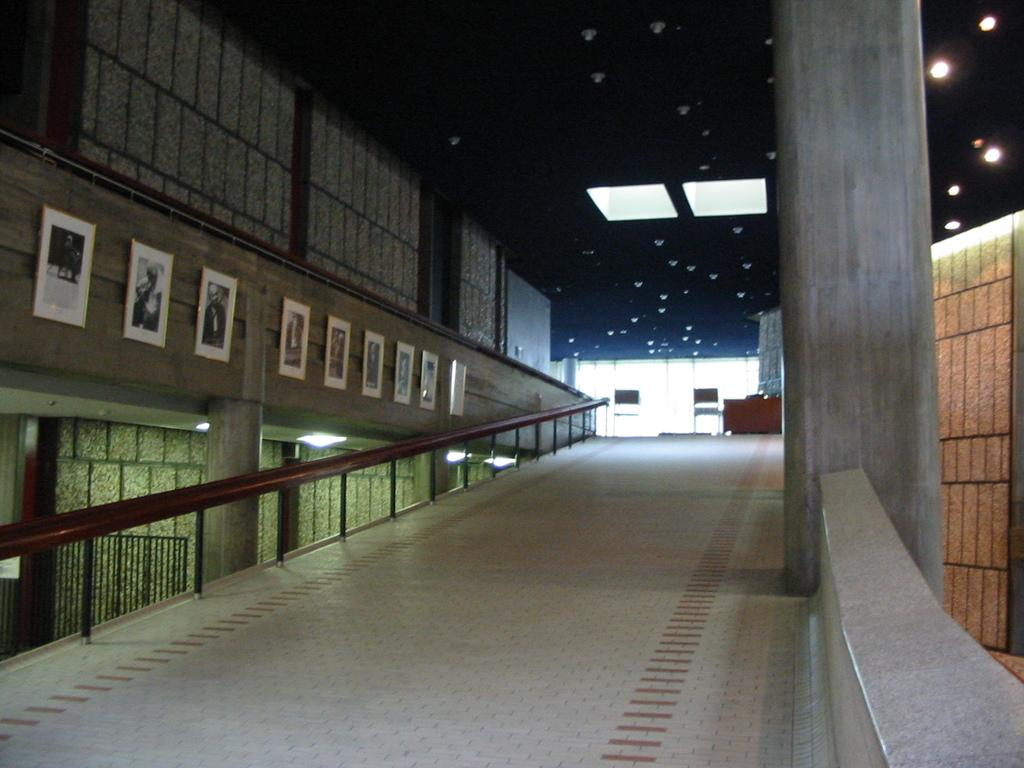What can be seen on the left side of the image? There is a railing on the left side of the image. What is present on the wall in the image? There are posters and frames on the wall in the image. What is located on the right side of the image? There is a pillar on the right side of the image. What is visible at the top of the image? There are lights visible at the top of the image. Can you see a dog playing in the park in the image? There is no dog or park present in the image. What is the back of the image made of? The back of the image is not visible in the provided facts, and therefore we cannot determine its material or composition. 